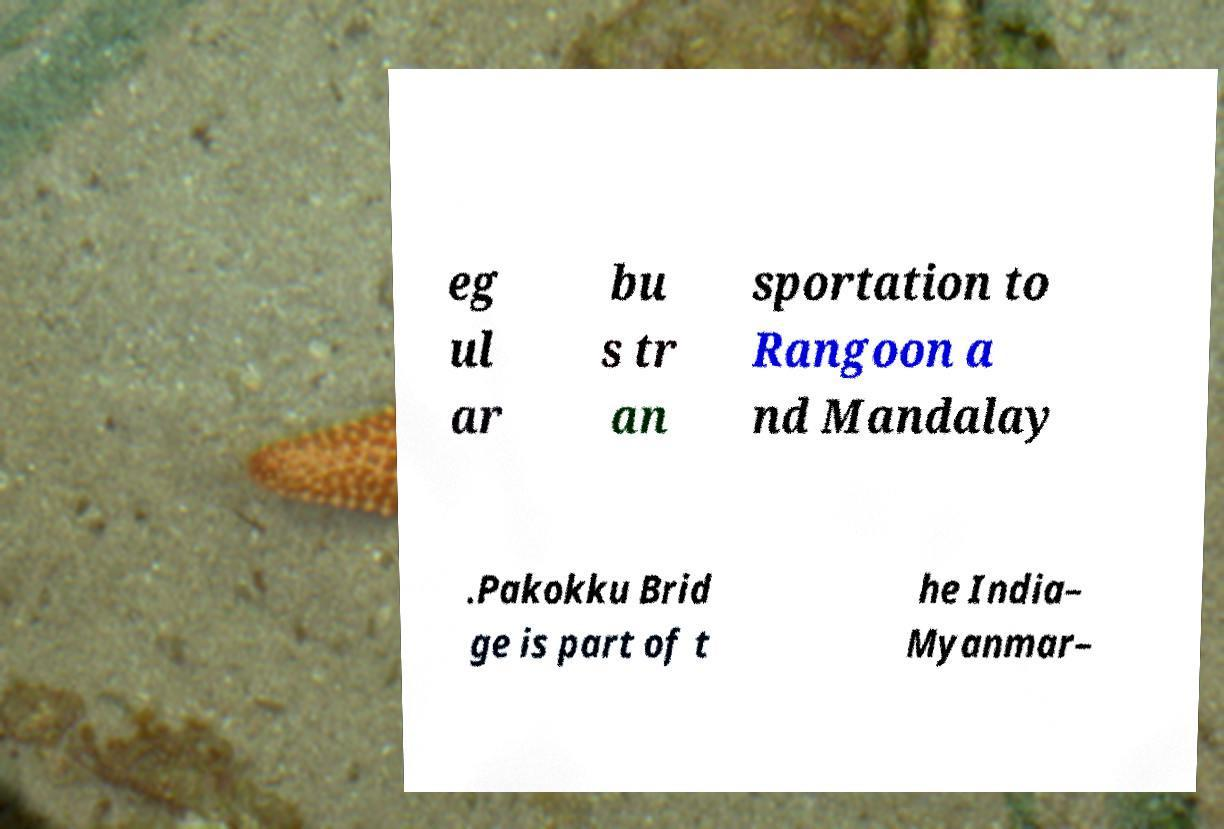For documentation purposes, I need the text within this image transcribed. Could you provide that? eg ul ar bu s tr an sportation to Rangoon a nd Mandalay .Pakokku Brid ge is part of t he India– Myanmar– 